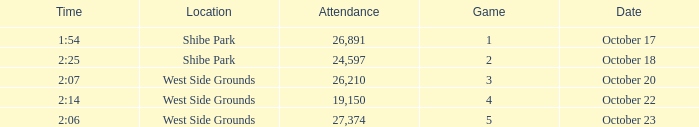For the game that was played on october 22 in west side grounds, what is the total attendance 1.0. 